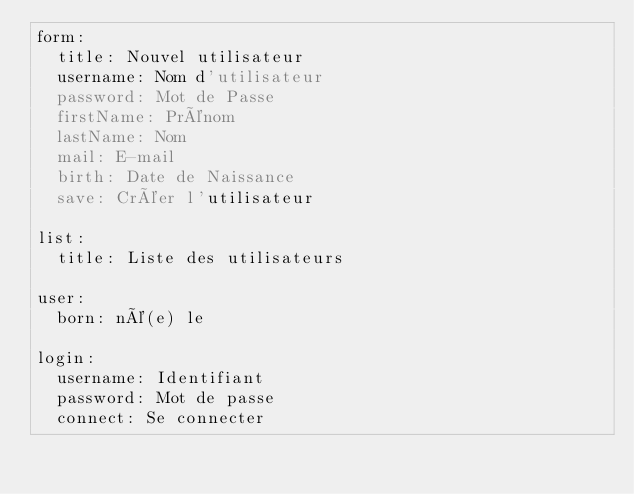<code> <loc_0><loc_0><loc_500><loc_500><_YAML_>form:
  title: Nouvel utilisateur
  username: Nom d'utilisateur
  password: Mot de Passe
  firstName: Prénom
  lastName: Nom
  mail: E-mail
  birth: Date de Naissance
  save: Créer l'utilisateur

list:
  title: Liste des utilisateurs

user:
  born: né(e) le

login:
  username: Identifiant
  password: Mot de passe
  connect: Se connecter
</code> 